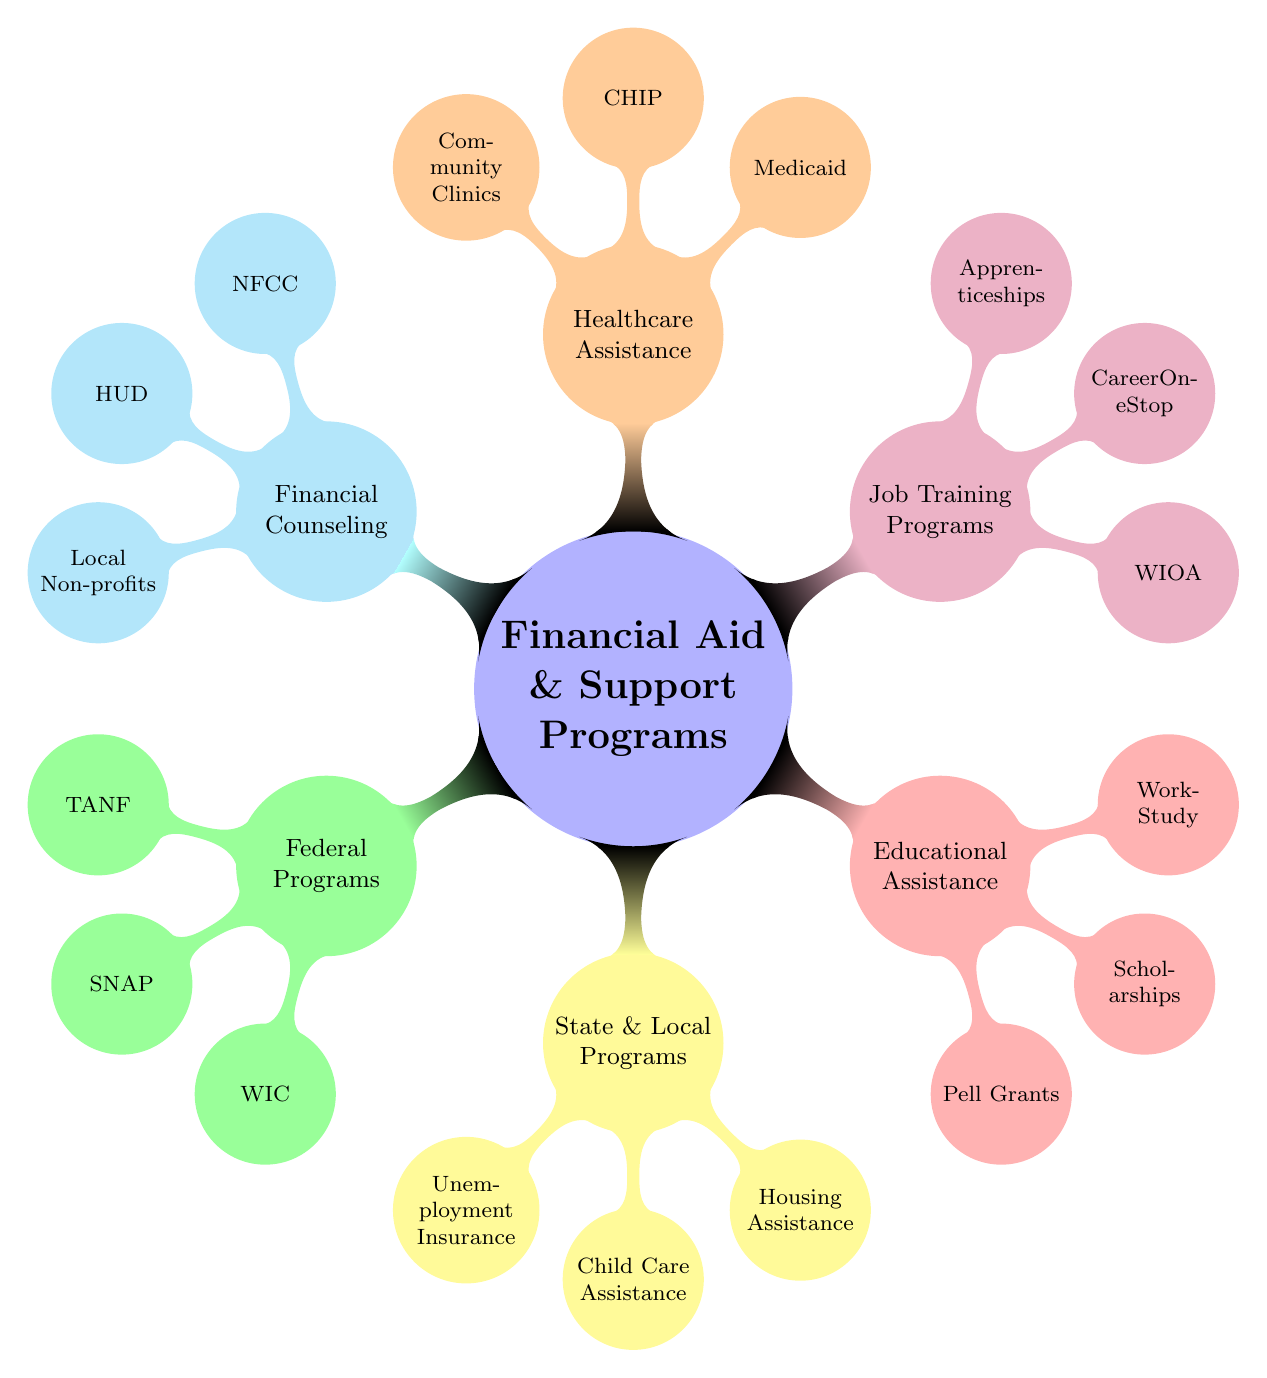What are the two federal programs listed in the diagram? The diagram lists three federal programs under "Federal Programs." Two of them are TANF (Temporary Assistance for Needy Families) and SNAP (Supplemental Nutrition Assistance Program).
Answer: TANF, SNAP How many state and local programs are mentioned? In the diagram, there are three programs listed under "State & Local Programs." They are Unemployment Insurance, Child Care Assistance, and Housing Assistance. Counting these gives a total of three programs.
Answer: 3 Which program provides educational assistance for single mothers? The diagram indicates a category called "Educational Assistance," which includes Pell Grants, Scholarships, and Work-Study. Any of these can be an answer, but focusing on one, Pell Grants is often a commonly recognized program.
Answer: Pell Grants What is the purpose of WIC as seen in the diagram? Within the federal programs section of the diagram, WIC stands for Women, Infants, and Children, suggesting it is focused on nutritional support. Therefore, its purpose is to provide nutritional assistance specifically targeted for women and their young children.
Answer: Nutritional assistance Which color represents job training programs in the diagram? In the mind map, Job Training Programs are represented by the color purple. By looking at the corresponding node's color, we can identify this.
Answer: Purple What type of assistance does the CHIP program provide? The CHIP program is categorized under Healthcare Assistance in the diagram. Since CHIP stands for Children's Health Insurance Program, it is specifically aimed at providing healthcare resources for children in low-income families.
Answer: Healthcare resources How are local non-profits categorized in the diagram? The diagram includes local non-profits under the "Financial Counseling" section. This categorization suggests that these non-profits provide financial counseling services for individuals, including single mothers.
Answer: Financial Counseling What does the acronym NFCC stand for? NFCC stands for the National Foundation for Credit Counseling. Reviewing the diagram under the financial counseling section clearly reveals this acronym.
Answer: National Foundation for Credit Counseling 